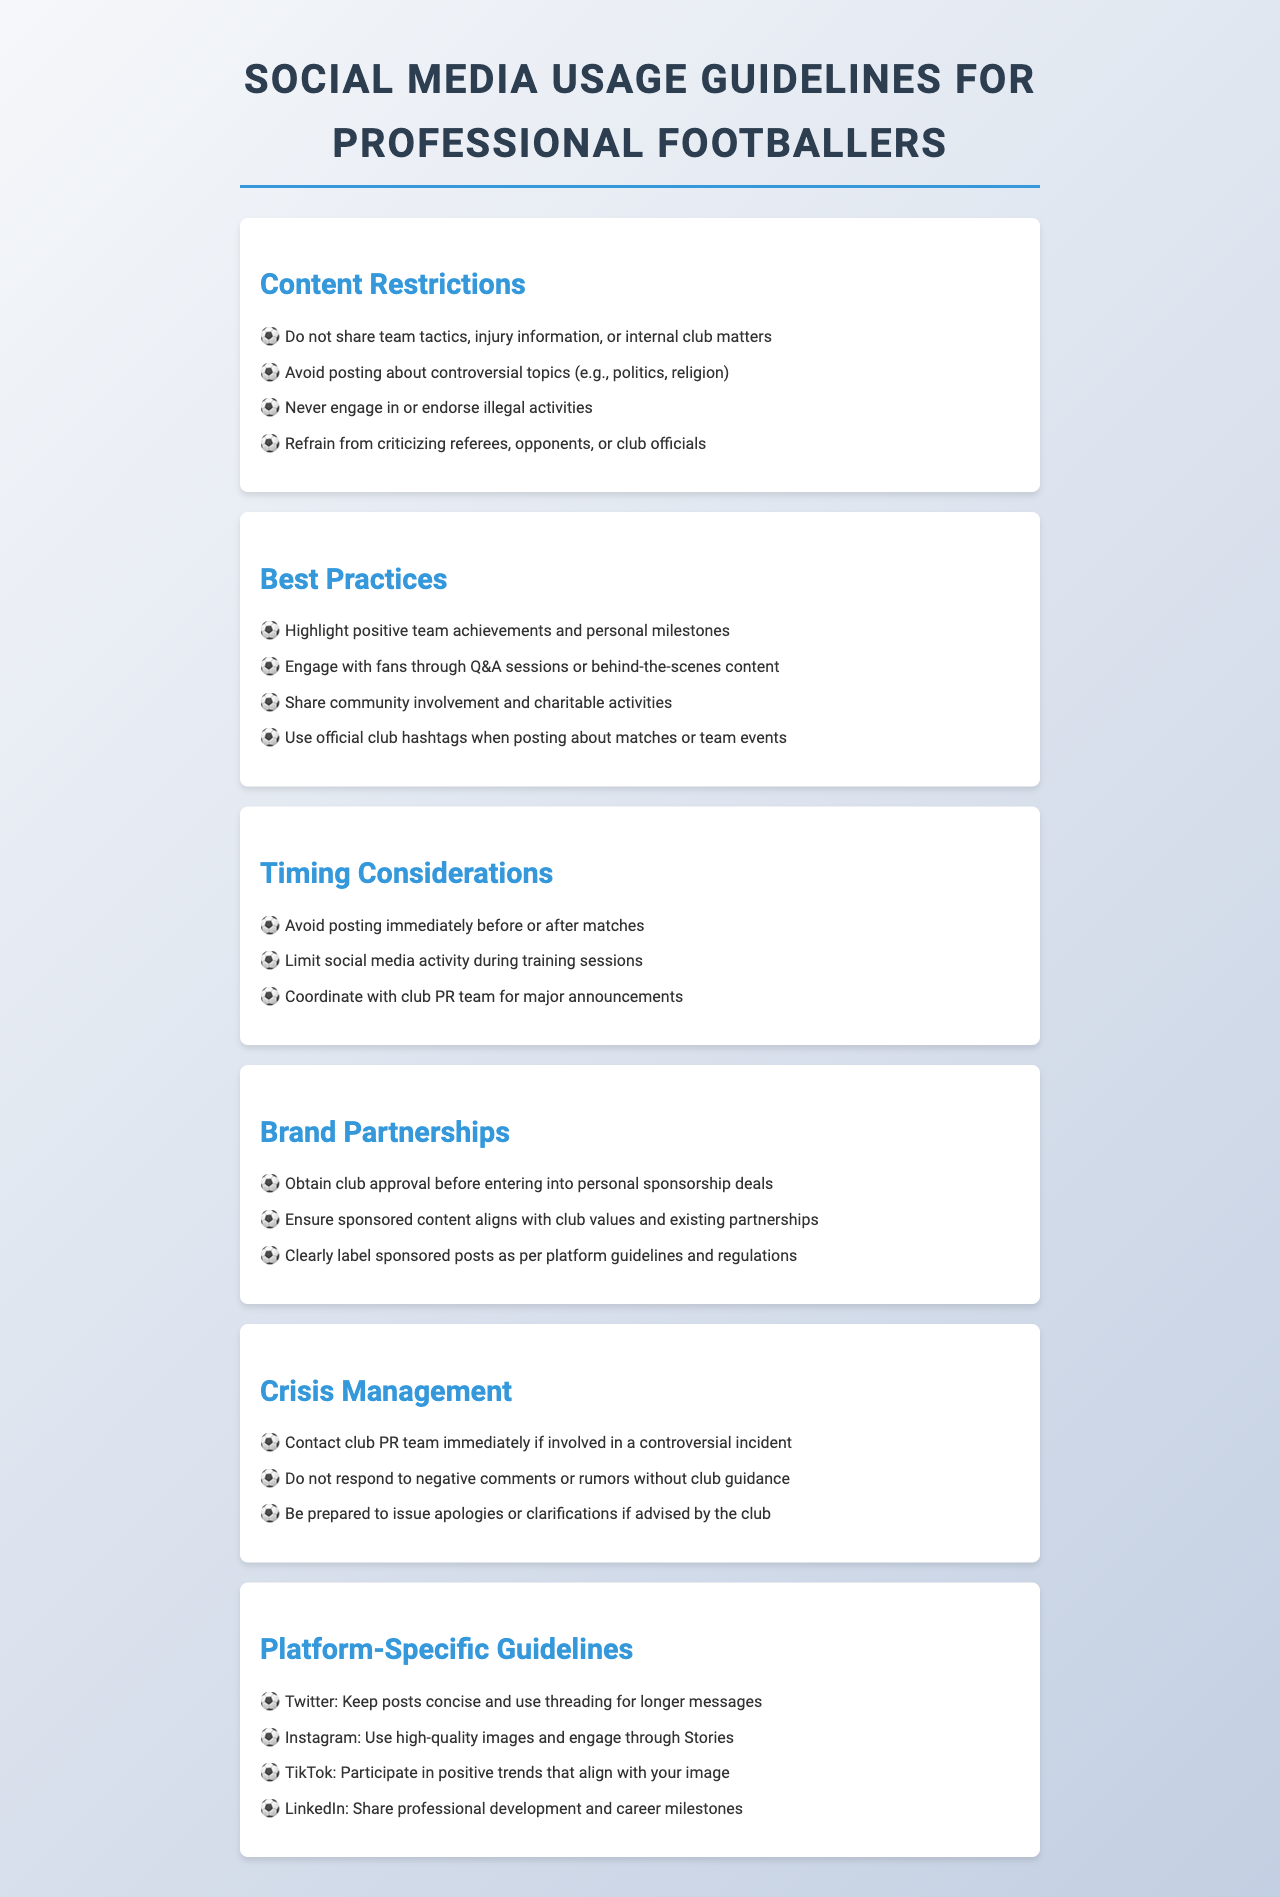What should you avoid posting about? The document lists specific topics to avoid, which include controversial topics such as politics and religion, among others.
Answer: Controversial topics What is a best practice for engaging with fans? The guidelines recommend interacting with fans through specific activities to enhance connection and engagement.
Answer: Q&A sessions What should you do before entering into personal sponsorship deals? The document advises that players need to ensure they follow certain steps before taking action regarding sponsorship.
Answer: Obtain club approval How should you manage social media during training sessions? There is guidance on the appropriate level of activity on social media during specific times related to training and matches.
Answer: Limit social media activity What action should you take if involved in a controversial incident? The document outlines the proper procedure to follow in the event of a dispute or issue that arises publicly.
Answer: Contact club PR team How should posts be labeled on social media? The guidelines emphasize the importance of adhering to regulations for sponsored content.
Answer: Clearly label sponsored posts What type of content should be shared on LinkedIn? The document includes platform-specific guidelines outlining appropriate content types to share on this professional networking platform.
Answer: Professional development Is it advisable to post immediately before or after matches? The timing of posts around matches is addressed to maintain focus on performance and events.
Answer: Avoid posting What is the main objective of these social media guidelines? The guidelines serve to assist players in maintaining a positive public image and effective communication through social media.
Answer: Positive public image 